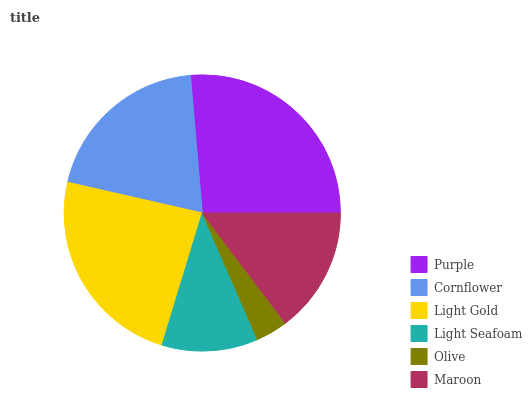Is Olive the minimum?
Answer yes or no. Yes. Is Purple the maximum?
Answer yes or no. Yes. Is Cornflower the minimum?
Answer yes or no. No. Is Cornflower the maximum?
Answer yes or no. No. Is Purple greater than Cornflower?
Answer yes or no. Yes. Is Cornflower less than Purple?
Answer yes or no. Yes. Is Cornflower greater than Purple?
Answer yes or no. No. Is Purple less than Cornflower?
Answer yes or no. No. Is Cornflower the high median?
Answer yes or no. Yes. Is Maroon the low median?
Answer yes or no. Yes. Is Light Seafoam the high median?
Answer yes or no. No. Is Cornflower the low median?
Answer yes or no. No. 